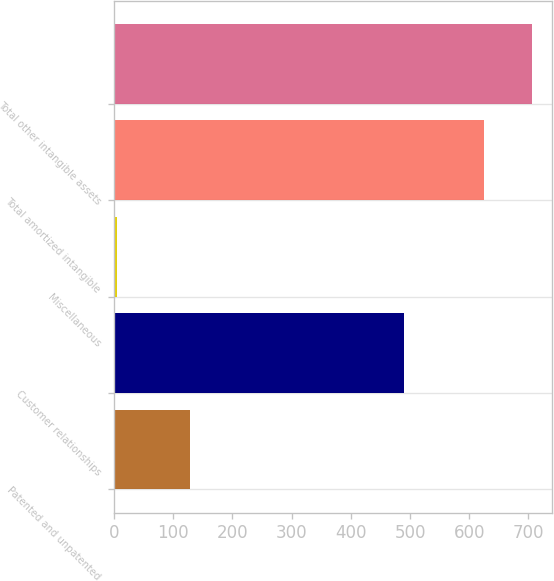<chart> <loc_0><loc_0><loc_500><loc_500><bar_chart><fcel>Patented and unpatented<fcel>Customer relationships<fcel>Miscellaneous<fcel>Total amortized intangible<fcel>Total other intangible assets<nl><fcel>128.7<fcel>490.3<fcel>5.6<fcel>624.6<fcel>705.3<nl></chart> 